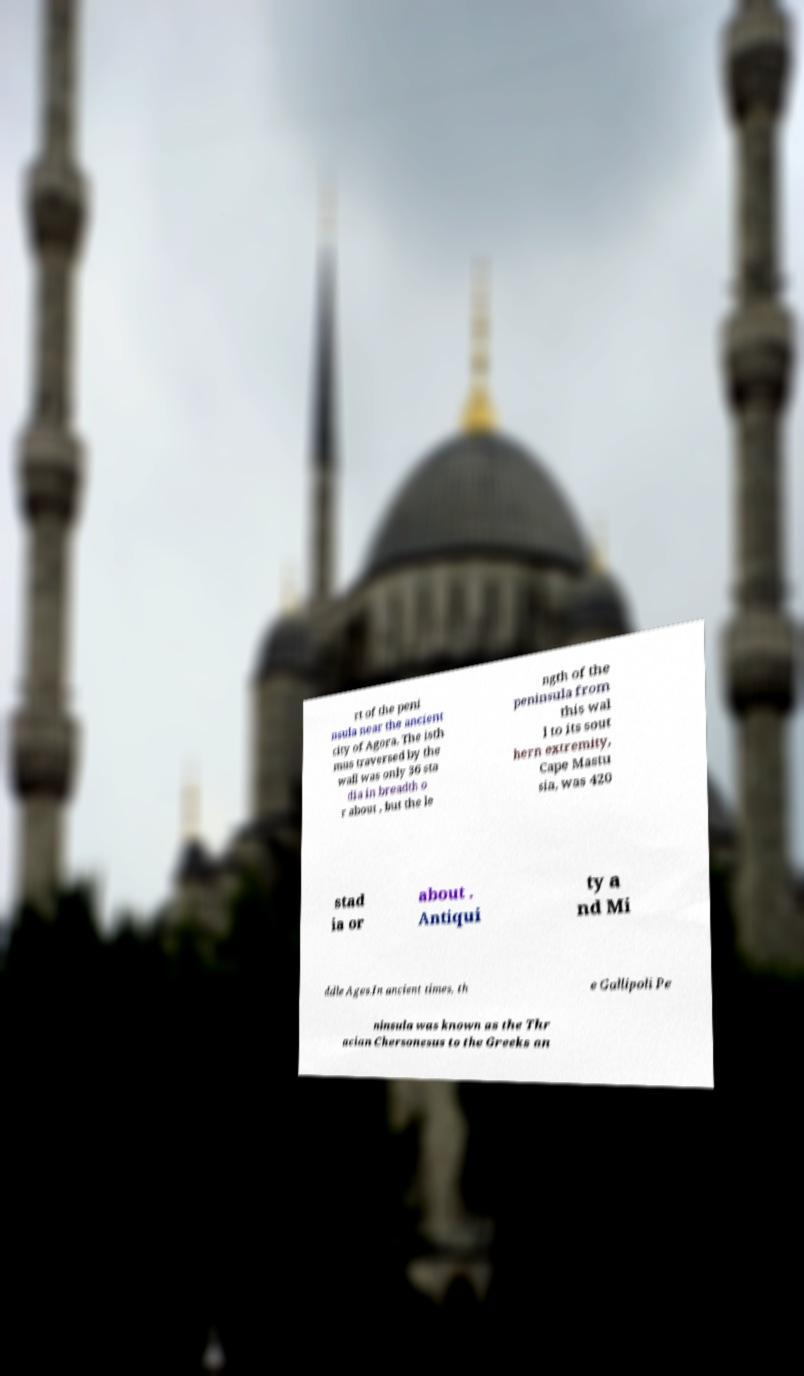For documentation purposes, I need the text within this image transcribed. Could you provide that? rt of the peni nsula near the ancient city of Agora. The isth mus traversed by the wall was only 36 sta dia in breadth o r about , but the le ngth of the peninsula from this wal l to its sout hern extremity, Cape Mastu sia, was 420 stad ia or about . Antiqui ty a nd Mi ddle Ages.In ancient times, th e Gallipoli Pe ninsula was known as the Thr acian Chersonesus to the Greeks an 